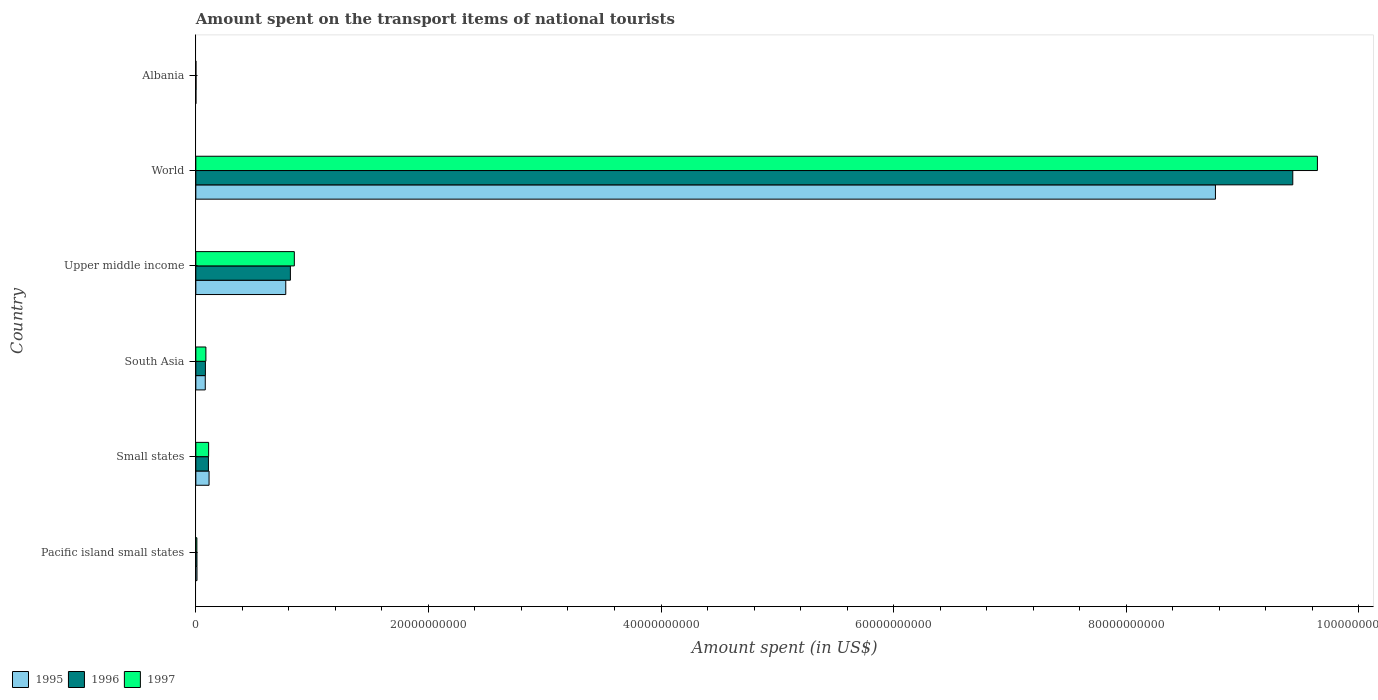How many groups of bars are there?
Provide a short and direct response. 6. How many bars are there on the 1st tick from the top?
Offer a very short reply. 3. How many bars are there on the 5th tick from the bottom?
Provide a succinct answer. 3. What is the label of the 3rd group of bars from the top?
Your answer should be compact. Upper middle income. What is the amount spent on the transport items of national tourists in 1996 in Pacific island small states?
Provide a succinct answer. 9.76e+07. Across all countries, what is the maximum amount spent on the transport items of national tourists in 1996?
Offer a terse response. 9.43e+1. Across all countries, what is the minimum amount spent on the transport items of national tourists in 1995?
Ensure brevity in your answer.  5.40e+06. In which country was the amount spent on the transport items of national tourists in 1997 maximum?
Ensure brevity in your answer.  World. In which country was the amount spent on the transport items of national tourists in 1997 minimum?
Make the answer very short. Albania. What is the total amount spent on the transport items of national tourists in 1996 in the graph?
Offer a very short reply. 1.04e+11. What is the difference between the amount spent on the transport items of national tourists in 1995 in Albania and that in South Asia?
Ensure brevity in your answer.  -8.07e+08. What is the difference between the amount spent on the transport items of national tourists in 1997 in Upper middle income and the amount spent on the transport items of national tourists in 1995 in South Asia?
Offer a very short reply. 7.66e+09. What is the average amount spent on the transport items of national tourists in 1995 per country?
Your response must be concise. 1.62e+1. What is the difference between the amount spent on the transport items of national tourists in 1996 and amount spent on the transport items of national tourists in 1997 in South Asia?
Give a very brief answer. -4.25e+07. What is the ratio of the amount spent on the transport items of national tourists in 1997 in Pacific island small states to that in South Asia?
Make the answer very short. 0.1. What is the difference between the highest and the second highest amount spent on the transport items of national tourists in 1995?
Your answer should be compact. 7.99e+1. What is the difference between the highest and the lowest amount spent on the transport items of national tourists in 1996?
Ensure brevity in your answer.  9.43e+1. Is the sum of the amount spent on the transport items of national tourists in 1996 in Pacific island small states and World greater than the maximum amount spent on the transport items of national tourists in 1995 across all countries?
Make the answer very short. Yes. What does the 2nd bar from the bottom in Pacific island small states represents?
Your answer should be compact. 1996. Is it the case that in every country, the sum of the amount spent on the transport items of national tourists in 1995 and amount spent on the transport items of national tourists in 1997 is greater than the amount spent on the transport items of national tourists in 1996?
Give a very brief answer. No. What is the difference between two consecutive major ticks on the X-axis?
Your answer should be compact. 2.00e+1. How are the legend labels stacked?
Your response must be concise. Horizontal. What is the title of the graph?
Provide a short and direct response. Amount spent on the transport items of national tourists. What is the label or title of the X-axis?
Provide a short and direct response. Amount spent (in US$). What is the label or title of the Y-axis?
Your answer should be compact. Country. What is the Amount spent (in US$) in 1995 in Pacific island small states?
Ensure brevity in your answer.  9.96e+07. What is the Amount spent (in US$) of 1996 in Pacific island small states?
Provide a succinct answer. 9.76e+07. What is the Amount spent (in US$) in 1997 in Pacific island small states?
Keep it short and to the point. 8.96e+07. What is the Amount spent (in US$) in 1995 in Small states?
Provide a succinct answer. 1.14e+09. What is the Amount spent (in US$) of 1996 in Small states?
Offer a terse response. 1.08e+09. What is the Amount spent (in US$) of 1997 in Small states?
Make the answer very short. 1.10e+09. What is the Amount spent (in US$) in 1995 in South Asia?
Give a very brief answer. 8.12e+08. What is the Amount spent (in US$) in 1996 in South Asia?
Your answer should be very brief. 8.23e+08. What is the Amount spent (in US$) of 1997 in South Asia?
Your answer should be compact. 8.66e+08. What is the Amount spent (in US$) of 1995 in Upper middle income?
Offer a very short reply. 7.73e+09. What is the Amount spent (in US$) of 1996 in Upper middle income?
Offer a very short reply. 8.13e+09. What is the Amount spent (in US$) in 1997 in Upper middle income?
Your answer should be compact. 8.47e+09. What is the Amount spent (in US$) of 1995 in World?
Your answer should be compact. 8.77e+1. What is the Amount spent (in US$) in 1996 in World?
Provide a succinct answer. 9.43e+1. What is the Amount spent (in US$) in 1997 in World?
Provide a succinct answer. 9.64e+1. What is the Amount spent (in US$) of 1995 in Albania?
Ensure brevity in your answer.  5.40e+06. What is the Amount spent (in US$) of 1996 in Albania?
Give a very brief answer. 1.68e+07. What is the Amount spent (in US$) in 1997 in Albania?
Offer a terse response. 6.60e+06. Across all countries, what is the maximum Amount spent (in US$) in 1995?
Make the answer very short. 8.77e+1. Across all countries, what is the maximum Amount spent (in US$) of 1996?
Give a very brief answer. 9.43e+1. Across all countries, what is the maximum Amount spent (in US$) of 1997?
Offer a terse response. 9.64e+1. Across all countries, what is the minimum Amount spent (in US$) of 1995?
Your response must be concise. 5.40e+06. Across all countries, what is the minimum Amount spent (in US$) of 1996?
Give a very brief answer. 1.68e+07. Across all countries, what is the minimum Amount spent (in US$) in 1997?
Ensure brevity in your answer.  6.60e+06. What is the total Amount spent (in US$) of 1995 in the graph?
Offer a terse response. 9.75e+1. What is the total Amount spent (in US$) in 1996 in the graph?
Ensure brevity in your answer.  1.04e+11. What is the total Amount spent (in US$) of 1997 in the graph?
Offer a terse response. 1.07e+11. What is the difference between the Amount spent (in US$) in 1995 in Pacific island small states and that in Small states?
Ensure brevity in your answer.  -1.04e+09. What is the difference between the Amount spent (in US$) of 1996 in Pacific island small states and that in Small states?
Offer a terse response. -9.86e+08. What is the difference between the Amount spent (in US$) in 1997 in Pacific island small states and that in Small states?
Provide a short and direct response. -1.01e+09. What is the difference between the Amount spent (in US$) in 1995 in Pacific island small states and that in South Asia?
Your response must be concise. -7.12e+08. What is the difference between the Amount spent (in US$) in 1996 in Pacific island small states and that in South Asia?
Offer a very short reply. -7.25e+08. What is the difference between the Amount spent (in US$) of 1997 in Pacific island small states and that in South Asia?
Make the answer very short. -7.76e+08. What is the difference between the Amount spent (in US$) of 1995 in Pacific island small states and that in Upper middle income?
Provide a short and direct response. -7.63e+09. What is the difference between the Amount spent (in US$) in 1996 in Pacific island small states and that in Upper middle income?
Ensure brevity in your answer.  -8.03e+09. What is the difference between the Amount spent (in US$) of 1997 in Pacific island small states and that in Upper middle income?
Your answer should be compact. -8.38e+09. What is the difference between the Amount spent (in US$) of 1995 in Pacific island small states and that in World?
Make the answer very short. -8.76e+1. What is the difference between the Amount spent (in US$) of 1996 in Pacific island small states and that in World?
Your answer should be very brief. -9.42e+1. What is the difference between the Amount spent (in US$) in 1997 in Pacific island small states and that in World?
Your response must be concise. -9.64e+1. What is the difference between the Amount spent (in US$) in 1995 in Pacific island small states and that in Albania?
Ensure brevity in your answer.  9.42e+07. What is the difference between the Amount spent (in US$) of 1996 in Pacific island small states and that in Albania?
Offer a very short reply. 8.08e+07. What is the difference between the Amount spent (in US$) of 1997 in Pacific island small states and that in Albania?
Provide a succinct answer. 8.30e+07. What is the difference between the Amount spent (in US$) in 1995 in Small states and that in South Asia?
Your response must be concise. 3.25e+08. What is the difference between the Amount spent (in US$) in 1996 in Small states and that in South Asia?
Your answer should be very brief. 2.60e+08. What is the difference between the Amount spent (in US$) of 1997 in Small states and that in South Asia?
Ensure brevity in your answer.  2.35e+08. What is the difference between the Amount spent (in US$) of 1995 in Small states and that in Upper middle income?
Your answer should be very brief. -6.60e+09. What is the difference between the Amount spent (in US$) of 1996 in Small states and that in Upper middle income?
Offer a very short reply. -7.05e+09. What is the difference between the Amount spent (in US$) in 1997 in Small states and that in Upper middle income?
Offer a terse response. -7.37e+09. What is the difference between the Amount spent (in US$) of 1995 in Small states and that in World?
Make the answer very short. -8.65e+1. What is the difference between the Amount spent (in US$) of 1996 in Small states and that in World?
Make the answer very short. -9.32e+1. What is the difference between the Amount spent (in US$) of 1997 in Small states and that in World?
Your response must be concise. -9.53e+1. What is the difference between the Amount spent (in US$) of 1995 in Small states and that in Albania?
Your response must be concise. 1.13e+09. What is the difference between the Amount spent (in US$) of 1996 in Small states and that in Albania?
Provide a succinct answer. 1.07e+09. What is the difference between the Amount spent (in US$) of 1997 in Small states and that in Albania?
Provide a succinct answer. 1.09e+09. What is the difference between the Amount spent (in US$) in 1995 in South Asia and that in Upper middle income?
Keep it short and to the point. -6.92e+09. What is the difference between the Amount spent (in US$) of 1996 in South Asia and that in Upper middle income?
Provide a short and direct response. -7.31e+09. What is the difference between the Amount spent (in US$) of 1997 in South Asia and that in Upper middle income?
Keep it short and to the point. -7.60e+09. What is the difference between the Amount spent (in US$) of 1995 in South Asia and that in World?
Offer a terse response. -8.69e+1. What is the difference between the Amount spent (in US$) in 1996 in South Asia and that in World?
Offer a very short reply. -9.35e+1. What is the difference between the Amount spent (in US$) in 1997 in South Asia and that in World?
Give a very brief answer. -9.56e+1. What is the difference between the Amount spent (in US$) of 1995 in South Asia and that in Albania?
Your answer should be compact. 8.07e+08. What is the difference between the Amount spent (in US$) of 1996 in South Asia and that in Albania?
Ensure brevity in your answer.  8.06e+08. What is the difference between the Amount spent (in US$) in 1997 in South Asia and that in Albania?
Your response must be concise. 8.59e+08. What is the difference between the Amount spent (in US$) in 1995 in Upper middle income and that in World?
Your answer should be very brief. -7.99e+1. What is the difference between the Amount spent (in US$) of 1996 in Upper middle income and that in World?
Give a very brief answer. -8.62e+1. What is the difference between the Amount spent (in US$) of 1997 in Upper middle income and that in World?
Make the answer very short. -8.80e+1. What is the difference between the Amount spent (in US$) of 1995 in Upper middle income and that in Albania?
Give a very brief answer. 7.73e+09. What is the difference between the Amount spent (in US$) of 1996 in Upper middle income and that in Albania?
Offer a terse response. 8.11e+09. What is the difference between the Amount spent (in US$) of 1997 in Upper middle income and that in Albania?
Ensure brevity in your answer.  8.46e+09. What is the difference between the Amount spent (in US$) of 1995 in World and that in Albania?
Your response must be concise. 8.77e+1. What is the difference between the Amount spent (in US$) in 1996 in World and that in Albania?
Keep it short and to the point. 9.43e+1. What is the difference between the Amount spent (in US$) in 1997 in World and that in Albania?
Give a very brief answer. 9.64e+1. What is the difference between the Amount spent (in US$) in 1995 in Pacific island small states and the Amount spent (in US$) in 1996 in Small states?
Your response must be concise. -9.84e+08. What is the difference between the Amount spent (in US$) in 1995 in Pacific island small states and the Amount spent (in US$) in 1997 in Small states?
Give a very brief answer. -1.00e+09. What is the difference between the Amount spent (in US$) in 1996 in Pacific island small states and the Amount spent (in US$) in 1997 in Small states?
Ensure brevity in your answer.  -1.00e+09. What is the difference between the Amount spent (in US$) in 1995 in Pacific island small states and the Amount spent (in US$) in 1996 in South Asia?
Offer a terse response. -7.23e+08. What is the difference between the Amount spent (in US$) of 1995 in Pacific island small states and the Amount spent (in US$) of 1997 in South Asia?
Make the answer very short. -7.66e+08. What is the difference between the Amount spent (in US$) in 1996 in Pacific island small states and the Amount spent (in US$) in 1997 in South Asia?
Make the answer very short. -7.68e+08. What is the difference between the Amount spent (in US$) of 1995 in Pacific island small states and the Amount spent (in US$) of 1996 in Upper middle income?
Offer a very short reply. -8.03e+09. What is the difference between the Amount spent (in US$) in 1995 in Pacific island small states and the Amount spent (in US$) in 1997 in Upper middle income?
Your response must be concise. -8.37e+09. What is the difference between the Amount spent (in US$) of 1996 in Pacific island small states and the Amount spent (in US$) of 1997 in Upper middle income?
Keep it short and to the point. -8.37e+09. What is the difference between the Amount spent (in US$) in 1995 in Pacific island small states and the Amount spent (in US$) in 1996 in World?
Offer a terse response. -9.42e+1. What is the difference between the Amount spent (in US$) of 1995 in Pacific island small states and the Amount spent (in US$) of 1997 in World?
Give a very brief answer. -9.63e+1. What is the difference between the Amount spent (in US$) in 1996 in Pacific island small states and the Amount spent (in US$) in 1997 in World?
Provide a succinct answer. -9.63e+1. What is the difference between the Amount spent (in US$) in 1995 in Pacific island small states and the Amount spent (in US$) in 1996 in Albania?
Offer a very short reply. 8.28e+07. What is the difference between the Amount spent (in US$) of 1995 in Pacific island small states and the Amount spent (in US$) of 1997 in Albania?
Provide a succinct answer. 9.30e+07. What is the difference between the Amount spent (in US$) in 1996 in Pacific island small states and the Amount spent (in US$) in 1997 in Albania?
Your response must be concise. 9.10e+07. What is the difference between the Amount spent (in US$) in 1995 in Small states and the Amount spent (in US$) in 1996 in South Asia?
Give a very brief answer. 3.15e+08. What is the difference between the Amount spent (in US$) of 1995 in Small states and the Amount spent (in US$) of 1997 in South Asia?
Your response must be concise. 2.72e+08. What is the difference between the Amount spent (in US$) in 1996 in Small states and the Amount spent (in US$) in 1997 in South Asia?
Give a very brief answer. 2.18e+08. What is the difference between the Amount spent (in US$) in 1995 in Small states and the Amount spent (in US$) in 1996 in Upper middle income?
Ensure brevity in your answer.  -6.99e+09. What is the difference between the Amount spent (in US$) in 1995 in Small states and the Amount spent (in US$) in 1997 in Upper middle income?
Your answer should be compact. -7.33e+09. What is the difference between the Amount spent (in US$) of 1996 in Small states and the Amount spent (in US$) of 1997 in Upper middle income?
Keep it short and to the point. -7.39e+09. What is the difference between the Amount spent (in US$) in 1995 in Small states and the Amount spent (in US$) in 1996 in World?
Your answer should be very brief. -9.32e+1. What is the difference between the Amount spent (in US$) of 1995 in Small states and the Amount spent (in US$) of 1997 in World?
Provide a short and direct response. -9.53e+1. What is the difference between the Amount spent (in US$) of 1996 in Small states and the Amount spent (in US$) of 1997 in World?
Make the answer very short. -9.54e+1. What is the difference between the Amount spent (in US$) of 1995 in Small states and the Amount spent (in US$) of 1996 in Albania?
Offer a very short reply. 1.12e+09. What is the difference between the Amount spent (in US$) in 1995 in Small states and the Amount spent (in US$) in 1997 in Albania?
Give a very brief answer. 1.13e+09. What is the difference between the Amount spent (in US$) in 1996 in Small states and the Amount spent (in US$) in 1997 in Albania?
Your response must be concise. 1.08e+09. What is the difference between the Amount spent (in US$) in 1995 in South Asia and the Amount spent (in US$) in 1996 in Upper middle income?
Your answer should be very brief. -7.32e+09. What is the difference between the Amount spent (in US$) in 1995 in South Asia and the Amount spent (in US$) in 1997 in Upper middle income?
Your answer should be compact. -7.66e+09. What is the difference between the Amount spent (in US$) in 1996 in South Asia and the Amount spent (in US$) in 1997 in Upper middle income?
Your response must be concise. -7.65e+09. What is the difference between the Amount spent (in US$) in 1995 in South Asia and the Amount spent (in US$) in 1996 in World?
Ensure brevity in your answer.  -9.35e+1. What is the difference between the Amount spent (in US$) of 1995 in South Asia and the Amount spent (in US$) of 1997 in World?
Offer a terse response. -9.56e+1. What is the difference between the Amount spent (in US$) of 1996 in South Asia and the Amount spent (in US$) of 1997 in World?
Give a very brief answer. -9.56e+1. What is the difference between the Amount spent (in US$) in 1995 in South Asia and the Amount spent (in US$) in 1996 in Albania?
Provide a short and direct response. 7.95e+08. What is the difference between the Amount spent (in US$) of 1995 in South Asia and the Amount spent (in US$) of 1997 in Albania?
Keep it short and to the point. 8.05e+08. What is the difference between the Amount spent (in US$) of 1996 in South Asia and the Amount spent (in US$) of 1997 in Albania?
Keep it short and to the point. 8.16e+08. What is the difference between the Amount spent (in US$) of 1995 in Upper middle income and the Amount spent (in US$) of 1996 in World?
Give a very brief answer. -8.66e+1. What is the difference between the Amount spent (in US$) in 1995 in Upper middle income and the Amount spent (in US$) in 1997 in World?
Offer a terse response. -8.87e+1. What is the difference between the Amount spent (in US$) of 1996 in Upper middle income and the Amount spent (in US$) of 1997 in World?
Your response must be concise. -8.83e+1. What is the difference between the Amount spent (in US$) in 1995 in Upper middle income and the Amount spent (in US$) in 1996 in Albania?
Provide a short and direct response. 7.72e+09. What is the difference between the Amount spent (in US$) of 1995 in Upper middle income and the Amount spent (in US$) of 1997 in Albania?
Keep it short and to the point. 7.73e+09. What is the difference between the Amount spent (in US$) of 1996 in Upper middle income and the Amount spent (in US$) of 1997 in Albania?
Your answer should be very brief. 8.12e+09. What is the difference between the Amount spent (in US$) in 1995 in World and the Amount spent (in US$) in 1996 in Albania?
Offer a terse response. 8.77e+1. What is the difference between the Amount spent (in US$) in 1995 in World and the Amount spent (in US$) in 1997 in Albania?
Provide a succinct answer. 8.77e+1. What is the difference between the Amount spent (in US$) in 1996 in World and the Amount spent (in US$) in 1997 in Albania?
Provide a short and direct response. 9.43e+1. What is the average Amount spent (in US$) in 1995 per country?
Offer a very short reply. 1.62e+1. What is the average Amount spent (in US$) in 1996 per country?
Ensure brevity in your answer.  1.74e+1. What is the average Amount spent (in US$) in 1997 per country?
Make the answer very short. 1.78e+1. What is the difference between the Amount spent (in US$) of 1995 and Amount spent (in US$) of 1996 in Pacific island small states?
Your answer should be compact. 1.99e+06. What is the difference between the Amount spent (in US$) in 1995 and Amount spent (in US$) in 1997 in Pacific island small states?
Provide a short and direct response. 9.93e+06. What is the difference between the Amount spent (in US$) of 1996 and Amount spent (in US$) of 1997 in Pacific island small states?
Provide a succinct answer. 7.94e+06. What is the difference between the Amount spent (in US$) in 1995 and Amount spent (in US$) in 1996 in Small states?
Offer a terse response. 5.44e+07. What is the difference between the Amount spent (in US$) in 1995 and Amount spent (in US$) in 1997 in Small states?
Offer a terse response. 3.69e+07. What is the difference between the Amount spent (in US$) of 1996 and Amount spent (in US$) of 1997 in Small states?
Offer a very short reply. -1.75e+07. What is the difference between the Amount spent (in US$) in 1995 and Amount spent (in US$) in 1996 in South Asia?
Provide a short and direct response. -1.09e+07. What is the difference between the Amount spent (in US$) of 1995 and Amount spent (in US$) of 1997 in South Asia?
Make the answer very short. -5.35e+07. What is the difference between the Amount spent (in US$) in 1996 and Amount spent (in US$) in 1997 in South Asia?
Offer a very short reply. -4.25e+07. What is the difference between the Amount spent (in US$) of 1995 and Amount spent (in US$) of 1996 in Upper middle income?
Make the answer very short. -3.97e+08. What is the difference between the Amount spent (in US$) in 1995 and Amount spent (in US$) in 1997 in Upper middle income?
Offer a very short reply. -7.36e+08. What is the difference between the Amount spent (in US$) of 1996 and Amount spent (in US$) of 1997 in Upper middle income?
Offer a very short reply. -3.39e+08. What is the difference between the Amount spent (in US$) in 1995 and Amount spent (in US$) in 1996 in World?
Make the answer very short. -6.65e+09. What is the difference between the Amount spent (in US$) of 1995 and Amount spent (in US$) of 1997 in World?
Offer a terse response. -8.77e+09. What is the difference between the Amount spent (in US$) of 1996 and Amount spent (in US$) of 1997 in World?
Your response must be concise. -2.12e+09. What is the difference between the Amount spent (in US$) of 1995 and Amount spent (in US$) of 1996 in Albania?
Make the answer very short. -1.14e+07. What is the difference between the Amount spent (in US$) of 1995 and Amount spent (in US$) of 1997 in Albania?
Provide a short and direct response. -1.20e+06. What is the difference between the Amount spent (in US$) of 1996 and Amount spent (in US$) of 1997 in Albania?
Give a very brief answer. 1.02e+07. What is the ratio of the Amount spent (in US$) of 1995 in Pacific island small states to that in Small states?
Your response must be concise. 0.09. What is the ratio of the Amount spent (in US$) of 1996 in Pacific island small states to that in Small states?
Offer a very short reply. 0.09. What is the ratio of the Amount spent (in US$) of 1997 in Pacific island small states to that in Small states?
Provide a succinct answer. 0.08. What is the ratio of the Amount spent (in US$) in 1995 in Pacific island small states to that in South Asia?
Your response must be concise. 0.12. What is the ratio of the Amount spent (in US$) in 1996 in Pacific island small states to that in South Asia?
Provide a short and direct response. 0.12. What is the ratio of the Amount spent (in US$) in 1997 in Pacific island small states to that in South Asia?
Offer a very short reply. 0.1. What is the ratio of the Amount spent (in US$) of 1995 in Pacific island small states to that in Upper middle income?
Offer a terse response. 0.01. What is the ratio of the Amount spent (in US$) in 1996 in Pacific island small states to that in Upper middle income?
Make the answer very short. 0.01. What is the ratio of the Amount spent (in US$) of 1997 in Pacific island small states to that in Upper middle income?
Offer a very short reply. 0.01. What is the ratio of the Amount spent (in US$) in 1995 in Pacific island small states to that in World?
Keep it short and to the point. 0. What is the ratio of the Amount spent (in US$) in 1997 in Pacific island small states to that in World?
Offer a terse response. 0. What is the ratio of the Amount spent (in US$) of 1995 in Pacific island small states to that in Albania?
Your response must be concise. 18.44. What is the ratio of the Amount spent (in US$) of 1996 in Pacific island small states to that in Albania?
Ensure brevity in your answer.  5.81. What is the ratio of the Amount spent (in US$) of 1997 in Pacific island small states to that in Albania?
Keep it short and to the point. 13.58. What is the ratio of the Amount spent (in US$) of 1995 in Small states to that in South Asia?
Your answer should be very brief. 1.4. What is the ratio of the Amount spent (in US$) in 1996 in Small states to that in South Asia?
Ensure brevity in your answer.  1.32. What is the ratio of the Amount spent (in US$) in 1997 in Small states to that in South Asia?
Ensure brevity in your answer.  1.27. What is the ratio of the Amount spent (in US$) in 1995 in Small states to that in Upper middle income?
Provide a short and direct response. 0.15. What is the ratio of the Amount spent (in US$) in 1996 in Small states to that in Upper middle income?
Your response must be concise. 0.13. What is the ratio of the Amount spent (in US$) in 1997 in Small states to that in Upper middle income?
Ensure brevity in your answer.  0.13. What is the ratio of the Amount spent (in US$) in 1995 in Small states to that in World?
Provide a succinct answer. 0.01. What is the ratio of the Amount spent (in US$) in 1996 in Small states to that in World?
Provide a short and direct response. 0.01. What is the ratio of the Amount spent (in US$) of 1997 in Small states to that in World?
Offer a terse response. 0.01. What is the ratio of the Amount spent (in US$) in 1995 in Small states to that in Albania?
Offer a very short reply. 210.65. What is the ratio of the Amount spent (in US$) of 1996 in Small states to that in Albania?
Ensure brevity in your answer.  64.47. What is the ratio of the Amount spent (in US$) in 1997 in Small states to that in Albania?
Offer a terse response. 166.76. What is the ratio of the Amount spent (in US$) in 1995 in South Asia to that in Upper middle income?
Provide a short and direct response. 0.1. What is the ratio of the Amount spent (in US$) in 1996 in South Asia to that in Upper middle income?
Your answer should be very brief. 0.1. What is the ratio of the Amount spent (in US$) of 1997 in South Asia to that in Upper middle income?
Ensure brevity in your answer.  0.1. What is the ratio of the Amount spent (in US$) of 1995 in South Asia to that in World?
Your answer should be compact. 0.01. What is the ratio of the Amount spent (in US$) of 1996 in South Asia to that in World?
Keep it short and to the point. 0.01. What is the ratio of the Amount spent (in US$) of 1997 in South Asia to that in World?
Give a very brief answer. 0.01. What is the ratio of the Amount spent (in US$) in 1995 in South Asia to that in Albania?
Your answer should be very brief. 150.38. What is the ratio of the Amount spent (in US$) of 1996 in South Asia to that in Albania?
Ensure brevity in your answer.  48.99. What is the ratio of the Amount spent (in US$) in 1997 in South Asia to that in Albania?
Give a very brief answer. 131.14. What is the ratio of the Amount spent (in US$) of 1995 in Upper middle income to that in World?
Offer a terse response. 0.09. What is the ratio of the Amount spent (in US$) of 1996 in Upper middle income to that in World?
Provide a short and direct response. 0.09. What is the ratio of the Amount spent (in US$) in 1997 in Upper middle income to that in World?
Ensure brevity in your answer.  0.09. What is the ratio of the Amount spent (in US$) in 1995 in Upper middle income to that in Albania?
Your answer should be compact. 1432.19. What is the ratio of the Amount spent (in US$) in 1996 in Upper middle income to that in Albania?
Provide a succinct answer. 483.97. What is the ratio of the Amount spent (in US$) of 1997 in Upper middle income to that in Albania?
Give a very brief answer. 1283.31. What is the ratio of the Amount spent (in US$) in 1995 in World to that in Albania?
Give a very brief answer. 1.62e+04. What is the ratio of the Amount spent (in US$) in 1996 in World to that in Albania?
Offer a terse response. 5614.52. What is the ratio of the Amount spent (in US$) of 1997 in World to that in Albania?
Your response must be concise. 1.46e+04. What is the difference between the highest and the second highest Amount spent (in US$) of 1995?
Make the answer very short. 7.99e+1. What is the difference between the highest and the second highest Amount spent (in US$) of 1996?
Your answer should be compact. 8.62e+1. What is the difference between the highest and the second highest Amount spent (in US$) in 1997?
Ensure brevity in your answer.  8.80e+1. What is the difference between the highest and the lowest Amount spent (in US$) in 1995?
Provide a short and direct response. 8.77e+1. What is the difference between the highest and the lowest Amount spent (in US$) in 1996?
Your answer should be very brief. 9.43e+1. What is the difference between the highest and the lowest Amount spent (in US$) of 1997?
Provide a short and direct response. 9.64e+1. 